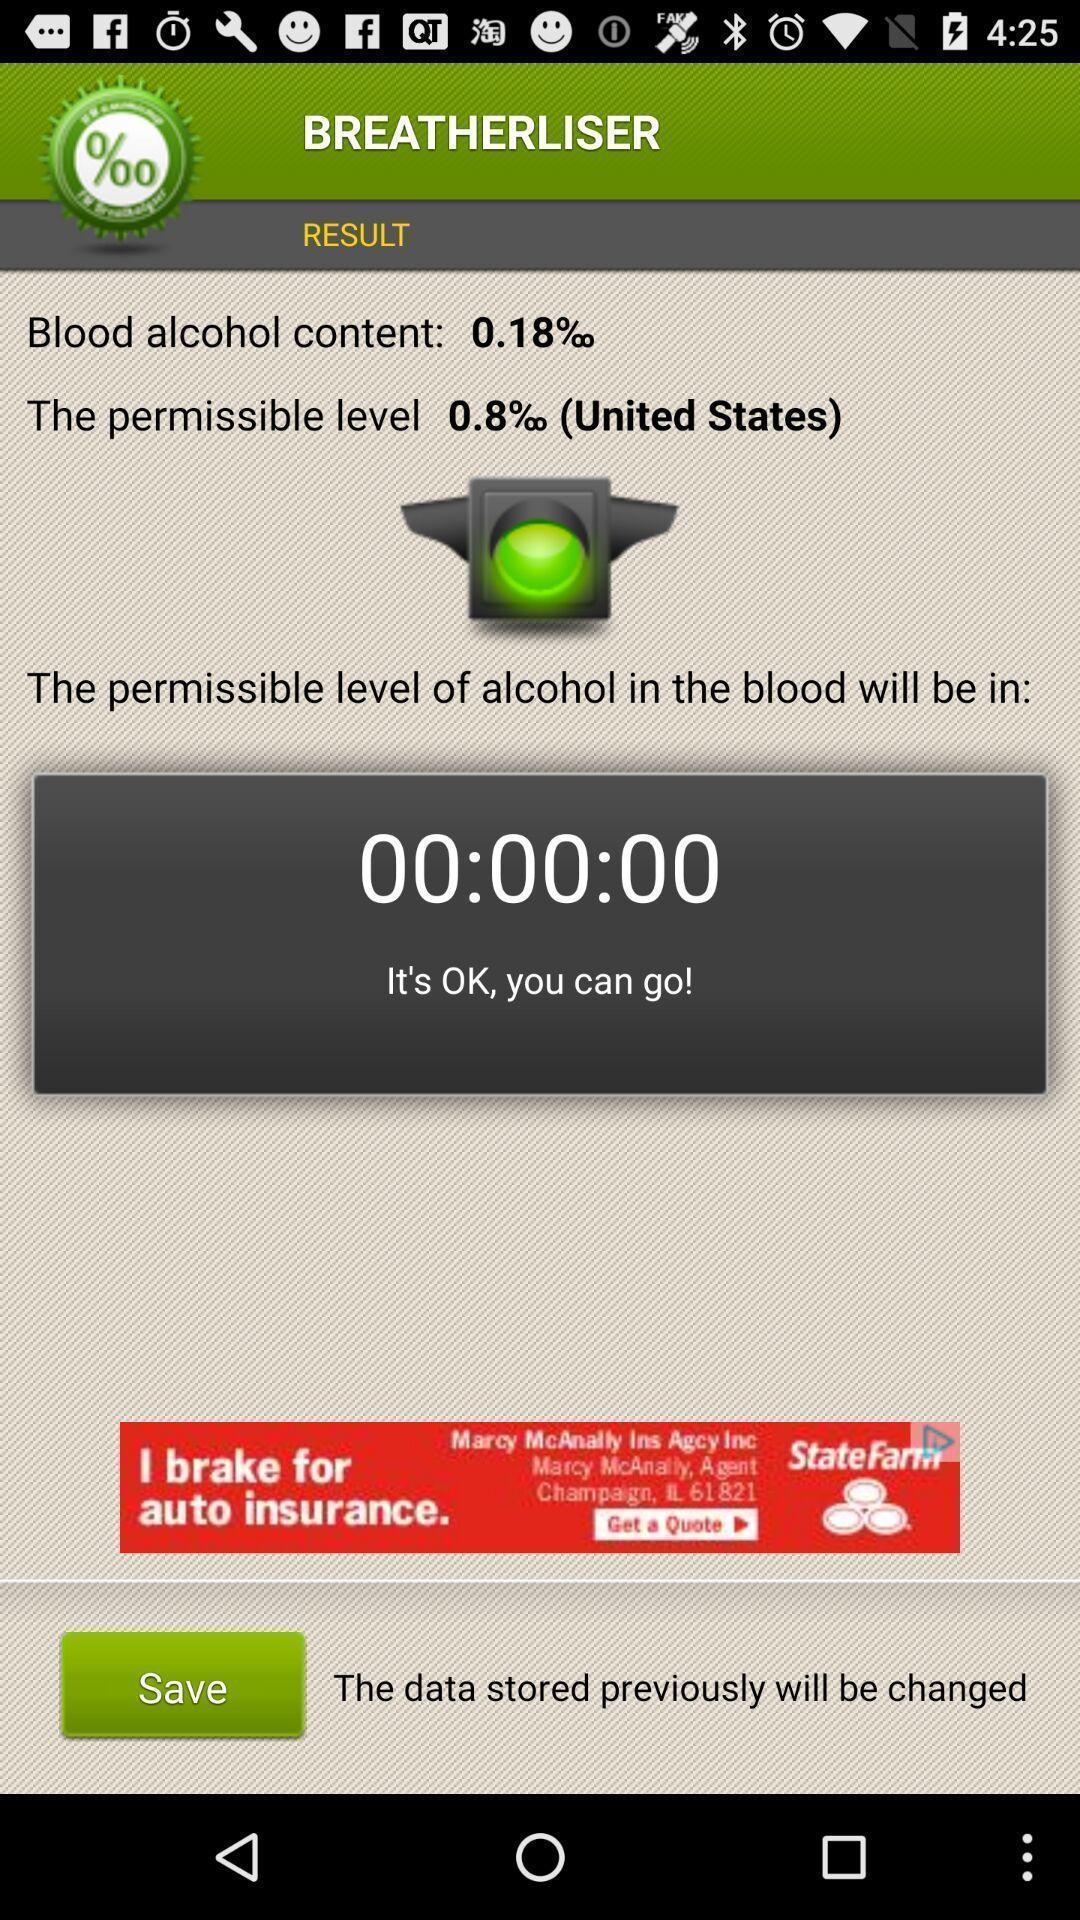What can you discern from this picture? Page shows the alcohol content details on breath analyses app. 